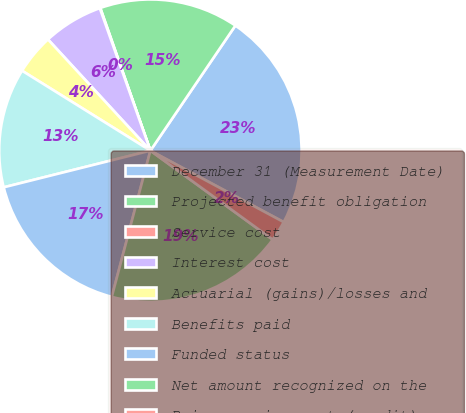<chart> <loc_0><loc_0><loc_500><loc_500><pie_chart><fcel>December 31 (Measurement Date)<fcel>Projected benefit obligation<fcel>Service cost<fcel>Interest cost<fcel>Actuarial (gains)/losses and<fcel>Benefits paid<fcel>Funded status<fcel>Net amount recognized on the<fcel>Prior service cost (credit)<nl><fcel>23.33%<fcel>14.87%<fcel>0.06%<fcel>6.41%<fcel>4.29%<fcel>12.76%<fcel>16.99%<fcel>19.1%<fcel>2.18%<nl></chart> 